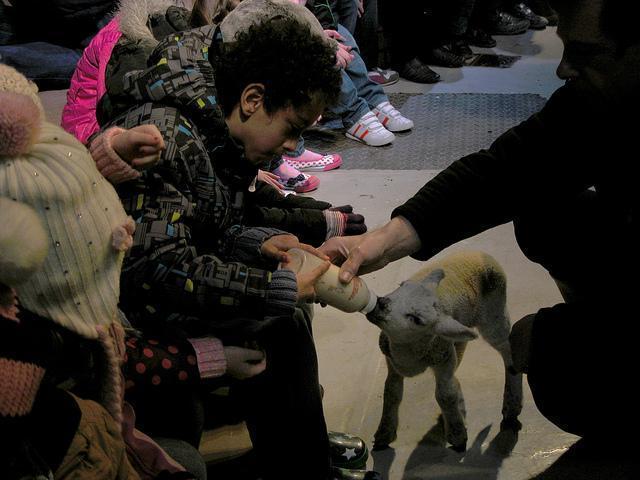How many animals can be seen?
Give a very brief answer. 1. How many people are in the picture?
Give a very brief answer. 8. How many chairs are on the right side of the tree?
Give a very brief answer. 0. 